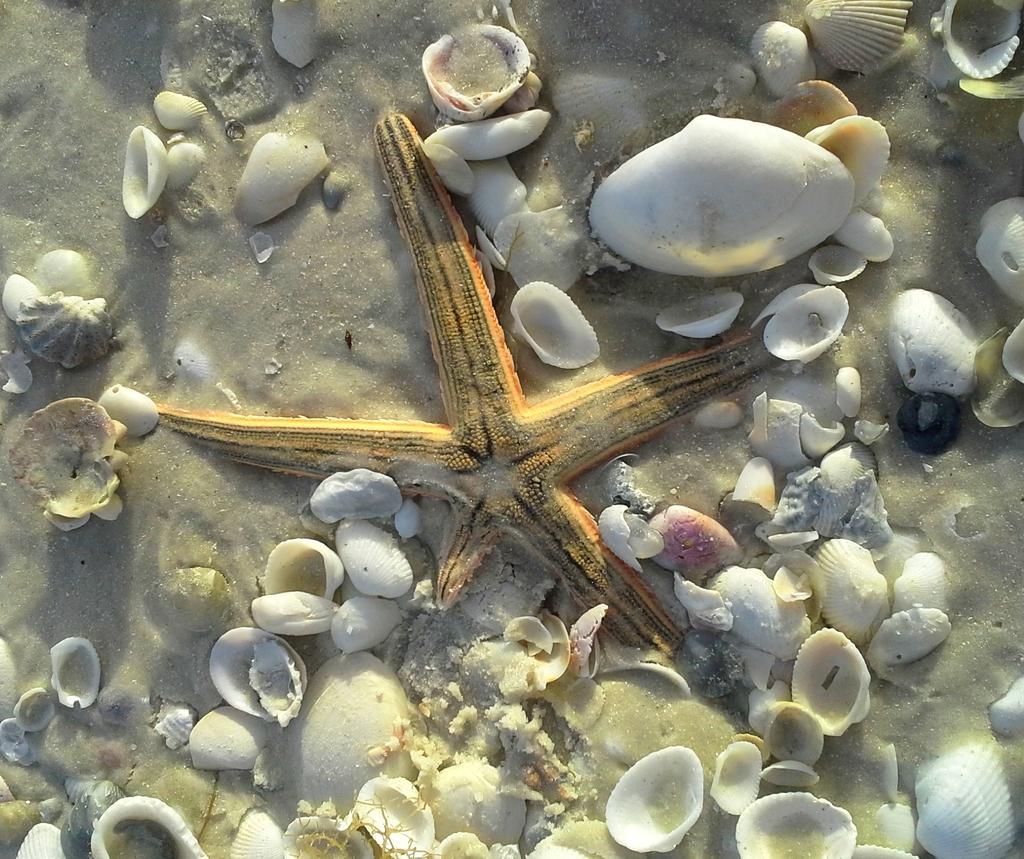Please provide a concise description of this image. In this picture I can observe starfish which is in yellow color. There are white color shells on the ground. I can observe different sizes of shells in this picture. 